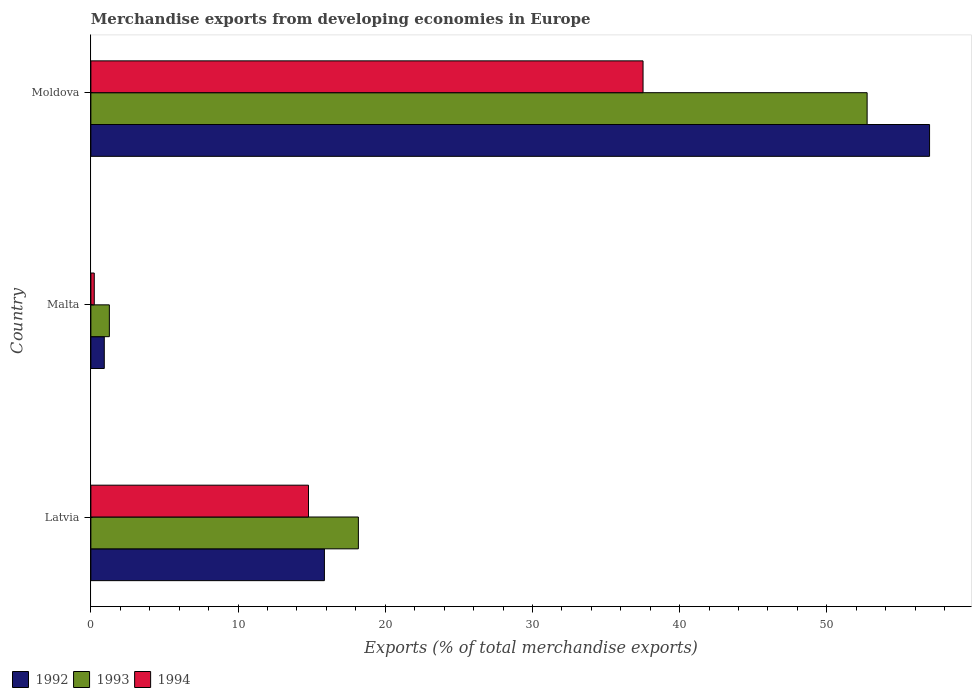How many different coloured bars are there?
Offer a very short reply. 3. How many bars are there on the 2nd tick from the bottom?
Make the answer very short. 3. What is the label of the 1st group of bars from the top?
Offer a terse response. Moldova. In how many cases, is the number of bars for a given country not equal to the number of legend labels?
Your answer should be very brief. 0. What is the percentage of total merchandise exports in 1994 in Latvia?
Make the answer very short. 14.79. Across all countries, what is the maximum percentage of total merchandise exports in 1994?
Keep it short and to the point. 37.51. Across all countries, what is the minimum percentage of total merchandise exports in 1993?
Keep it short and to the point. 1.26. In which country was the percentage of total merchandise exports in 1992 maximum?
Your answer should be compact. Moldova. In which country was the percentage of total merchandise exports in 1993 minimum?
Your answer should be very brief. Malta. What is the total percentage of total merchandise exports in 1993 in the graph?
Your answer should be compact. 72.17. What is the difference between the percentage of total merchandise exports in 1994 in Latvia and that in Moldova?
Keep it short and to the point. -22.73. What is the difference between the percentage of total merchandise exports in 1994 in Moldova and the percentage of total merchandise exports in 1992 in Latvia?
Make the answer very short. 21.65. What is the average percentage of total merchandise exports in 1994 per country?
Ensure brevity in your answer.  17.51. What is the difference between the percentage of total merchandise exports in 1994 and percentage of total merchandise exports in 1992 in Latvia?
Keep it short and to the point. -1.08. In how many countries, is the percentage of total merchandise exports in 1993 greater than 24 %?
Your answer should be very brief. 1. What is the ratio of the percentage of total merchandise exports in 1994 in Malta to that in Moldova?
Provide a succinct answer. 0.01. What is the difference between the highest and the second highest percentage of total merchandise exports in 1994?
Your response must be concise. 22.73. What is the difference between the highest and the lowest percentage of total merchandise exports in 1992?
Keep it short and to the point. 56.07. In how many countries, is the percentage of total merchandise exports in 1994 greater than the average percentage of total merchandise exports in 1994 taken over all countries?
Offer a terse response. 1. Is the sum of the percentage of total merchandise exports in 1993 in Latvia and Moldova greater than the maximum percentage of total merchandise exports in 1994 across all countries?
Ensure brevity in your answer.  Yes. What does the 1st bar from the bottom in Malta represents?
Offer a very short reply. 1992. How many bars are there?
Provide a short and direct response. 9. How many countries are there in the graph?
Provide a short and direct response. 3. Does the graph contain grids?
Provide a short and direct response. No. Where does the legend appear in the graph?
Give a very brief answer. Bottom left. How many legend labels are there?
Offer a very short reply. 3. How are the legend labels stacked?
Your response must be concise. Horizontal. What is the title of the graph?
Your answer should be compact. Merchandise exports from developing economies in Europe. Does "2007" appear as one of the legend labels in the graph?
Your answer should be compact. No. What is the label or title of the X-axis?
Your response must be concise. Exports (% of total merchandise exports). What is the label or title of the Y-axis?
Offer a very short reply. Country. What is the Exports (% of total merchandise exports) of 1992 in Latvia?
Provide a short and direct response. 15.87. What is the Exports (% of total merchandise exports) of 1993 in Latvia?
Provide a short and direct response. 18.17. What is the Exports (% of total merchandise exports) of 1994 in Latvia?
Ensure brevity in your answer.  14.79. What is the Exports (% of total merchandise exports) in 1992 in Malta?
Ensure brevity in your answer.  0.91. What is the Exports (% of total merchandise exports) in 1993 in Malta?
Your answer should be compact. 1.26. What is the Exports (% of total merchandise exports) of 1994 in Malta?
Offer a terse response. 0.23. What is the Exports (% of total merchandise exports) of 1992 in Moldova?
Your answer should be compact. 56.98. What is the Exports (% of total merchandise exports) in 1993 in Moldova?
Offer a terse response. 52.74. What is the Exports (% of total merchandise exports) of 1994 in Moldova?
Your answer should be compact. 37.51. Across all countries, what is the maximum Exports (% of total merchandise exports) of 1992?
Your answer should be very brief. 56.98. Across all countries, what is the maximum Exports (% of total merchandise exports) of 1993?
Ensure brevity in your answer.  52.74. Across all countries, what is the maximum Exports (% of total merchandise exports) in 1994?
Ensure brevity in your answer.  37.51. Across all countries, what is the minimum Exports (% of total merchandise exports) in 1992?
Your answer should be very brief. 0.91. Across all countries, what is the minimum Exports (% of total merchandise exports) of 1993?
Your answer should be compact. 1.26. Across all countries, what is the minimum Exports (% of total merchandise exports) in 1994?
Provide a short and direct response. 0.23. What is the total Exports (% of total merchandise exports) of 1992 in the graph?
Offer a very short reply. 73.75. What is the total Exports (% of total merchandise exports) in 1993 in the graph?
Make the answer very short. 72.17. What is the total Exports (% of total merchandise exports) of 1994 in the graph?
Your answer should be very brief. 52.53. What is the difference between the Exports (% of total merchandise exports) in 1992 in Latvia and that in Malta?
Offer a terse response. 14.96. What is the difference between the Exports (% of total merchandise exports) of 1993 in Latvia and that in Malta?
Offer a terse response. 16.92. What is the difference between the Exports (% of total merchandise exports) in 1994 in Latvia and that in Malta?
Your response must be concise. 14.56. What is the difference between the Exports (% of total merchandise exports) in 1992 in Latvia and that in Moldova?
Give a very brief answer. -41.11. What is the difference between the Exports (% of total merchandise exports) in 1993 in Latvia and that in Moldova?
Give a very brief answer. -34.56. What is the difference between the Exports (% of total merchandise exports) in 1994 in Latvia and that in Moldova?
Keep it short and to the point. -22.73. What is the difference between the Exports (% of total merchandise exports) in 1992 in Malta and that in Moldova?
Ensure brevity in your answer.  -56.07. What is the difference between the Exports (% of total merchandise exports) in 1993 in Malta and that in Moldova?
Provide a succinct answer. -51.48. What is the difference between the Exports (% of total merchandise exports) in 1994 in Malta and that in Moldova?
Provide a short and direct response. -37.28. What is the difference between the Exports (% of total merchandise exports) in 1992 in Latvia and the Exports (% of total merchandise exports) in 1993 in Malta?
Ensure brevity in your answer.  14.61. What is the difference between the Exports (% of total merchandise exports) in 1992 in Latvia and the Exports (% of total merchandise exports) in 1994 in Malta?
Ensure brevity in your answer.  15.64. What is the difference between the Exports (% of total merchandise exports) of 1993 in Latvia and the Exports (% of total merchandise exports) of 1994 in Malta?
Offer a terse response. 17.94. What is the difference between the Exports (% of total merchandise exports) of 1992 in Latvia and the Exports (% of total merchandise exports) of 1993 in Moldova?
Your answer should be very brief. -36.87. What is the difference between the Exports (% of total merchandise exports) in 1992 in Latvia and the Exports (% of total merchandise exports) in 1994 in Moldova?
Ensure brevity in your answer.  -21.65. What is the difference between the Exports (% of total merchandise exports) in 1993 in Latvia and the Exports (% of total merchandise exports) in 1994 in Moldova?
Your answer should be compact. -19.34. What is the difference between the Exports (% of total merchandise exports) of 1992 in Malta and the Exports (% of total merchandise exports) of 1993 in Moldova?
Give a very brief answer. -51.83. What is the difference between the Exports (% of total merchandise exports) in 1992 in Malta and the Exports (% of total merchandise exports) in 1994 in Moldova?
Give a very brief answer. -36.6. What is the difference between the Exports (% of total merchandise exports) in 1993 in Malta and the Exports (% of total merchandise exports) in 1994 in Moldova?
Your response must be concise. -36.26. What is the average Exports (% of total merchandise exports) of 1992 per country?
Ensure brevity in your answer.  24.58. What is the average Exports (% of total merchandise exports) in 1993 per country?
Ensure brevity in your answer.  24.06. What is the average Exports (% of total merchandise exports) in 1994 per country?
Provide a succinct answer. 17.51. What is the difference between the Exports (% of total merchandise exports) of 1992 and Exports (% of total merchandise exports) of 1993 in Latvia?
Provide a succinct answer. -2.31. What is the difference between the Exports (% of total merchandise exports) in 1992 and Exports (% of total merchandise exports) in 1994 in Latvia?
Make the answer very short. 1.08. What is the difference between the Exports (% of total merchandise exports) in 1993 and Exports (% of total merchandise exports) in 1994 in Latvia?
Your answer should be very brief. 3.39. What is the difference between the Exports (% of total merchandise exports) of 1992 and Exports (% of total merchandise exports) of 1993 in Malta?
Your answer should be very brief. -0.34. What is the difference between the Exports (% of total merchandise exports) in 1992 and Exports (% of total merchandise exports) in 1994 in Malta?
Make the answer very short. 0.68. What is the difference between the Exports (% of total merchandise exports) of 1993 and Exports (% of total merchandise exports) of 1994 in Malta?
Give a very brief answer. 1.03. What is the difference between the Exports (% of total merchandise exports) in 1992 and Exports (% of total merchandise exports) in 1993 in Moldova?
Keep it short and to the point. 4.24. What is the difference between the Exports (% of total merchandise exports) of 1992 and Exports (% of total merchandise exports) of 1994 in Moldova?
Make the answer very short. 19.47. What is the difference between the Exports (% of total merchandise exports) of 1993 and Exports (% of total merchandise exports) of 1994 in Moldova?
Ensure brevity in your answer.  15.22. What is the ratio of the Exports (% of total merchandise exports) of 1992 in Latvia to that in Malta?
Offer a terse response. 17.43. What is the ratio of the Exports (% of total merchandise exports) in 1993 in Latvia to that in Malta?
Give a very brief answer. 14.48. What is the ratio of the Exports (% of total merchandise exports) of 1994 in Latvia to that in Malta?
Provide a succinct answer. 64.38. What is the ratio of the Exports (% of total merchandise exports) in 1992 in Latvia to that in Moldova?
Offer a very short reply. 0.28. What is the ratio of the Exports (% of total merchandise exports) in 1993 in Latvia to that in Moldova?
Your response must be concise. 0.34. What is the ratio of the Exports (% of total merchandise exports) of 1994 in Latvia to that in Moldova?
Offer a terse response. 0.39. What is the ratio of the Exports (% of total merchandise exports) of 1992 in Malta to that in Moldova?
Provide a short and direct response. 0.02. What is the ratio of the Exports (% of total merchandise exports) in 1993 in Malta to that in Moldova?
Make the answer very short. 0.02. What is the ratio of the Exports (% of total merchandise exports) of 1994 in Malta to that in Moldova?
Make the answer very short. 0.01. What is the difference between the highest and the second highest Exports (% of total merchandise exports) of 1992?
Offer a terse response. 41.11. What is the difference between the highest and the second highest Exports (% of total merchandise exports) in 1993?
Provide a short and direct response. 34.56. What is the difference between the highest and the second highest Exports (% of total merchandise exports) of 1994?
Keep it short and to the point. 22.73. What is the difference between the highest and the lowest Exports (% of total merchandise exports) of 1992?
Your answer should be very brief. 56.07. What is the difference between the highest and the lowest Exports (% of total merchandise exports) in 1993?
Keep it short and to the point. 51.48. What is the difference between the highest and the lowest Exports (% of total merchandise exports) of 1994?
Make the answer very short. 37.28. 